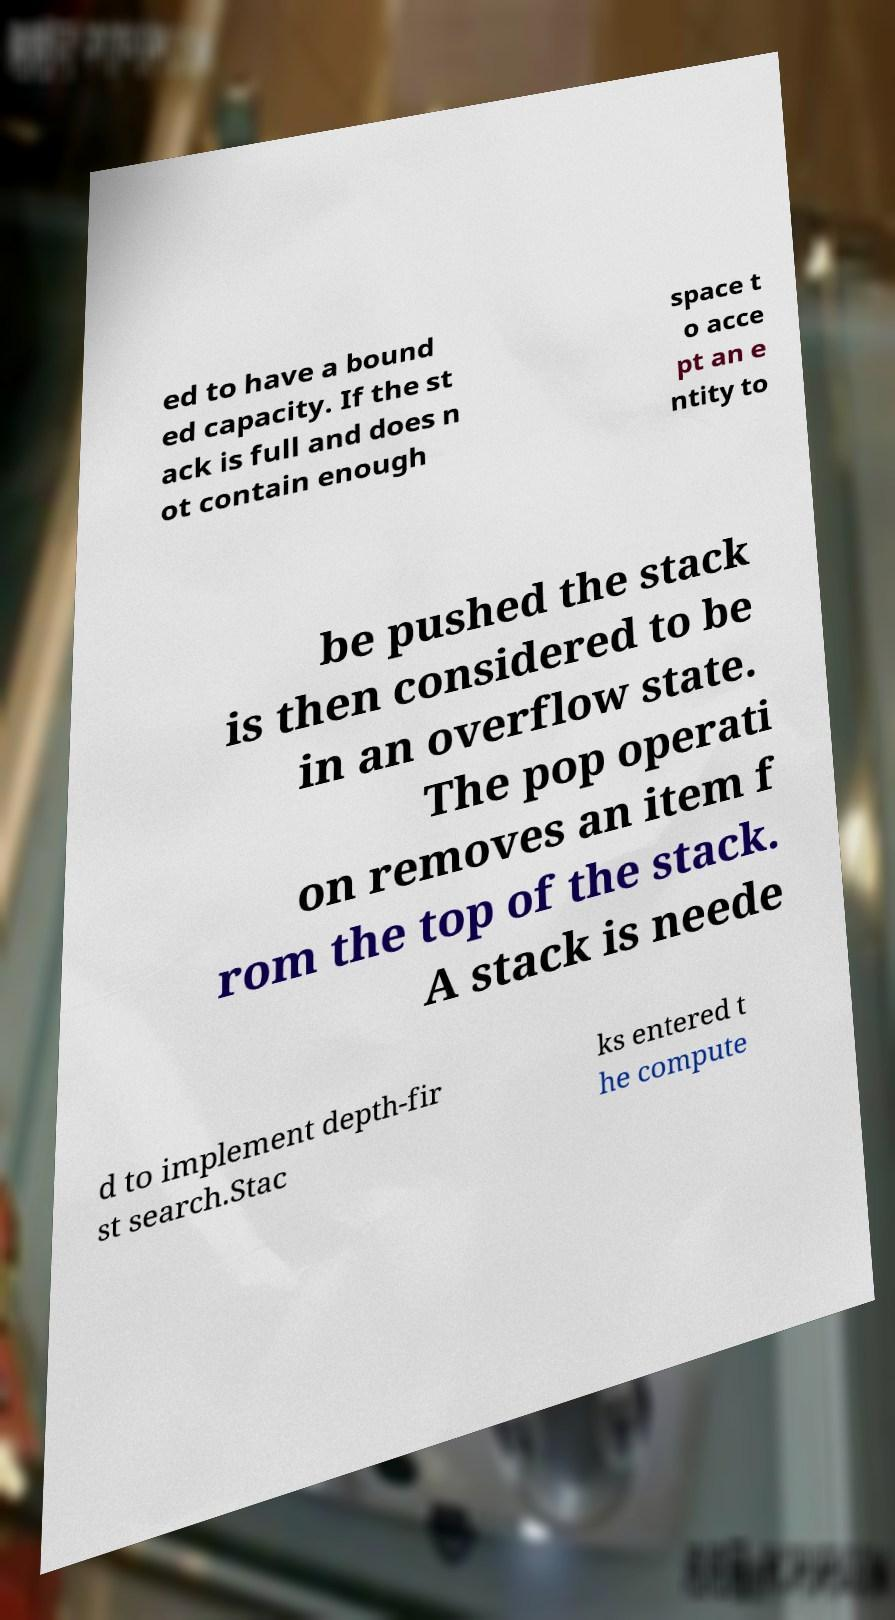Could you extract and type out the text from this image? ed to have a bound ed capacity. If the st ack is full and does n ot contain enough space t o acce pt an e ntity to be pushed the stack is then considered to be in an overflow state. The pop operati on removes an item f rom the top of the stack. A stack is neede d to implement depth-fir st search.Stac ks entered t he compute 